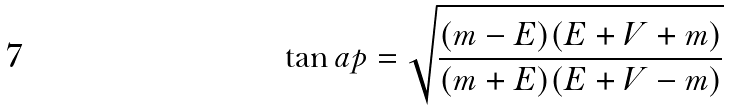Convert formula to latex. <formula><loc_0><loc_0><loc_500><loc_500>\tan a p = \sqrt { \frac { ( m - E ) ( E + V + m ) } { ( m + E ) ( E + V - m ) } }</formula> 